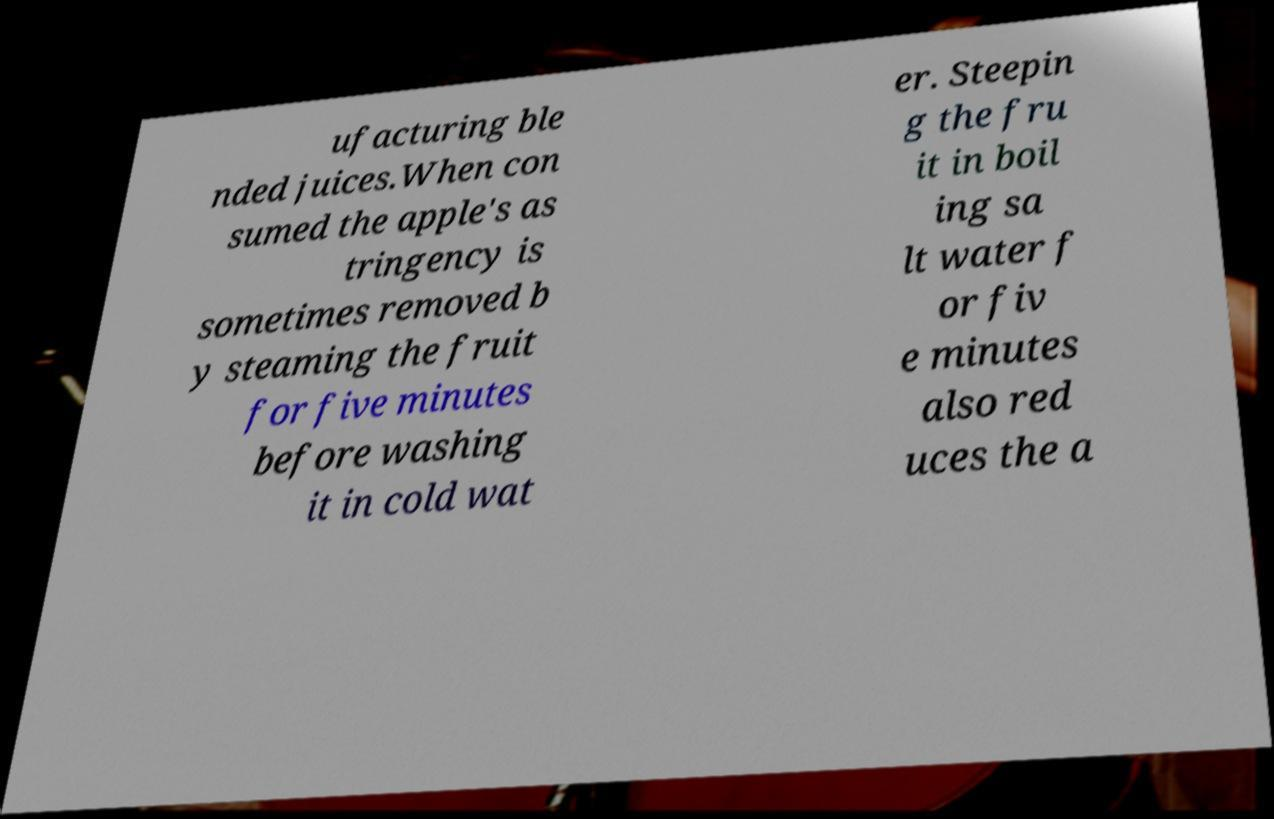There's text embedded in this image that I need extracted. Can you transcribe it verbatim? ufacturing ble nded juices.When con sumed the apple's as tringency is sometimes removed b y steaming the fruit for five minutes before washing it in cold wat er. Steepin g the fru it in boil ing sa lt water f or fiv e minutes also red uces the a 